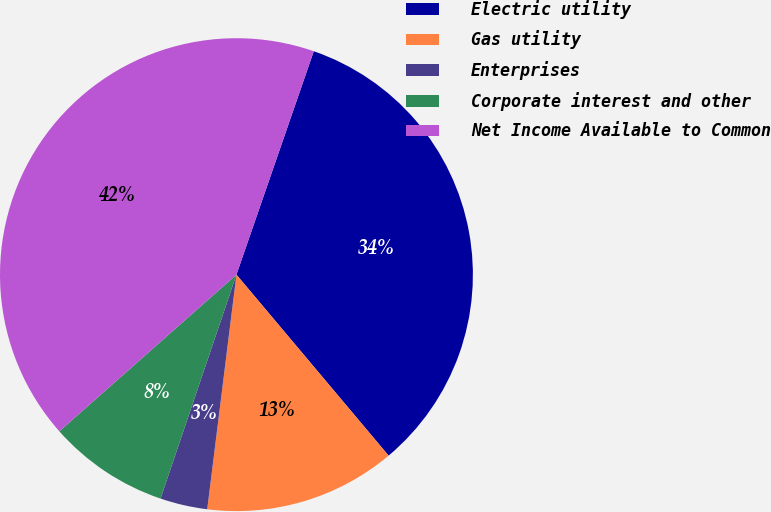Convert chart to OTSL. <chart><loc_0><loc_0><loc_500><loc_500><pie_chart><fcel>Electric utility<fcel>Gas utility<fcel>Enterprises<fcel>Corporate interest and other<fcel>Net Income Available to Common<nl><fcel>33.57%<fcel>13.1%<fcel>3.23%<fcel>8.27%<fcel>41.83%<nl></chart> 